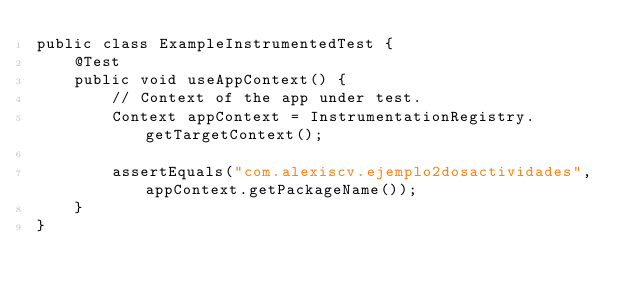<code> <loc_0><loc_0><loc_500><loc_500><_Java_>public class ExampleInstrumentedTest {
    @Test
    public void useAppContext() {
        // Context of the app under test.
        Context appContext = InstrumentationRegistry.getTargetContext();

        assertEquals("com.alexiscv.ejemplo2dosactividades", appContext.getPackageName());
    }
}
</code> 